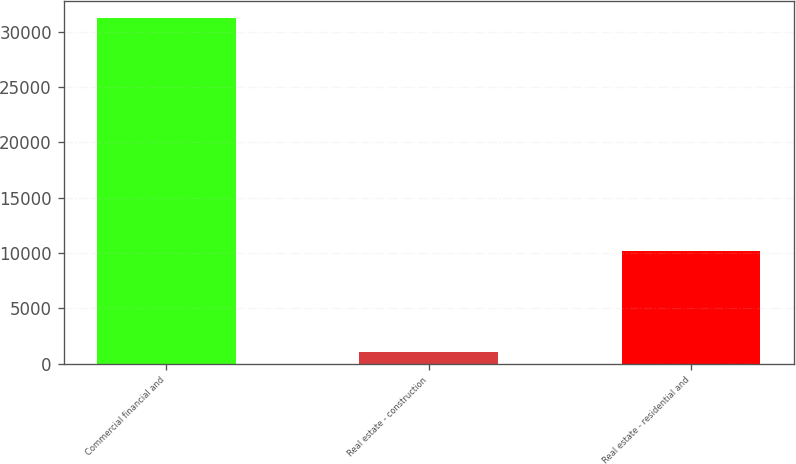Convert chart to OTSL. <chart><loc_0><loc_0><loc_500><loc_500><bar_chart><fcel>Commercial financial and<fcel>Real estate - construction<fcel>Real estate - residential and<nl><fcel>31240<fcel>1053<fcel>10201<nl></chart> 